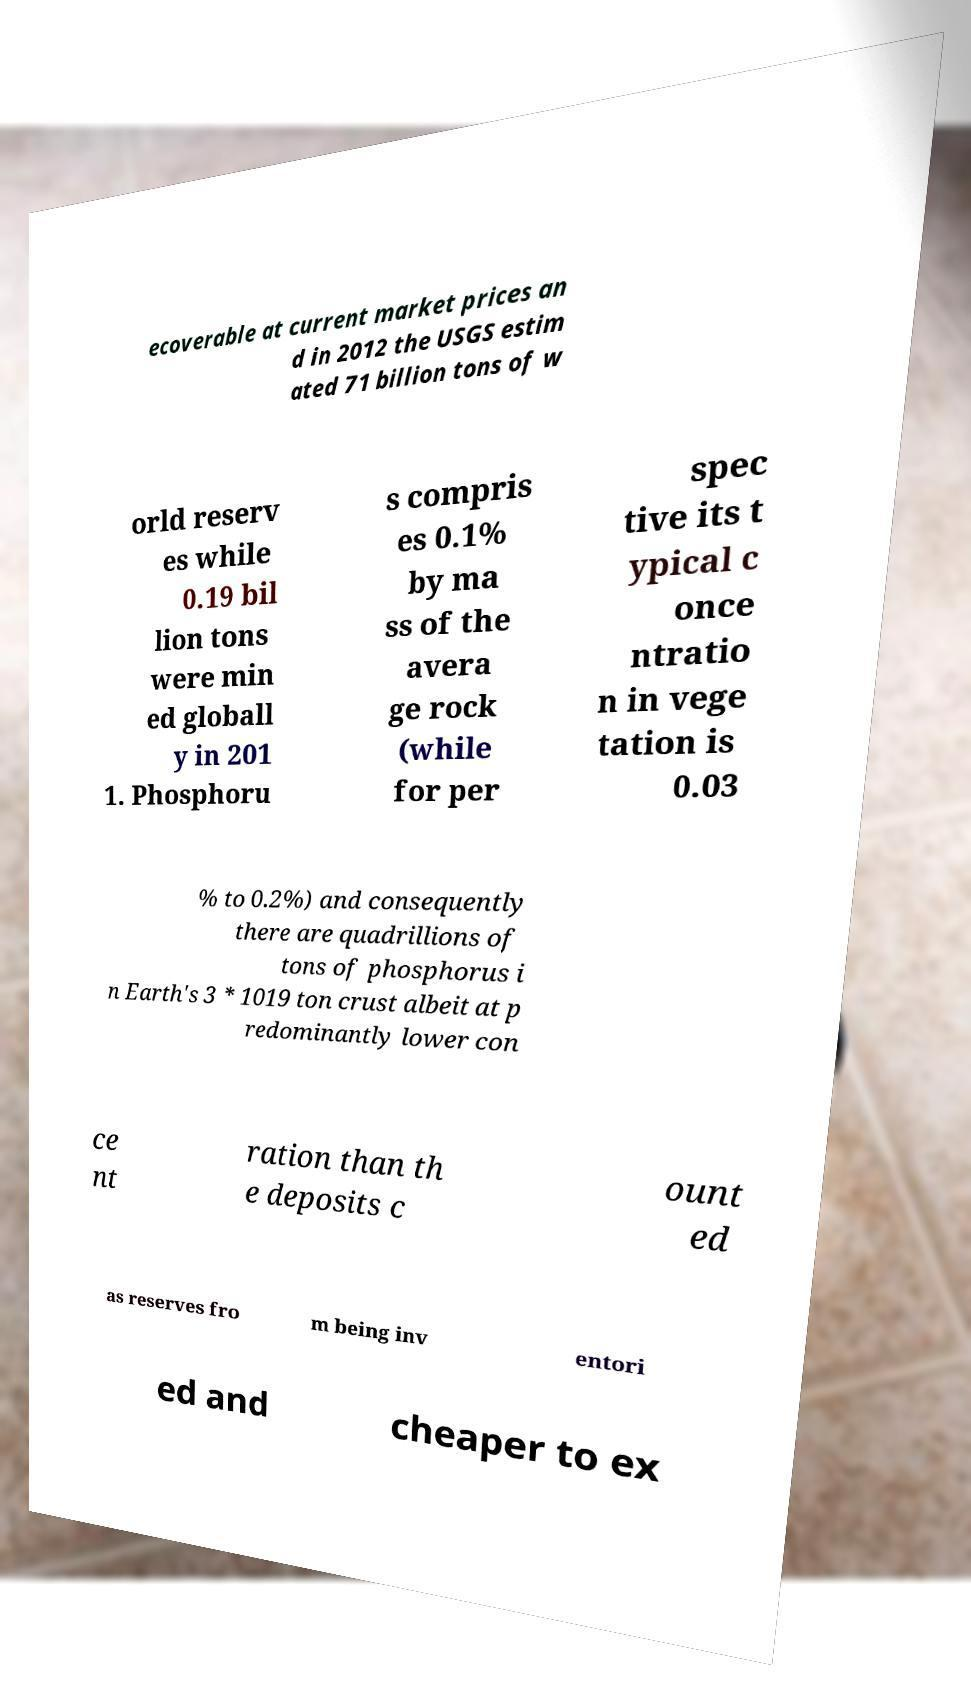Please read and relay the text visible in this image. What does it say? ecoverable at current market prices an d in 2012 the USGS estim ated 71 billion tons of w orld reserv es while 0.19 bil lion tons were min ed globall y in 201 1. Phosphoru s compris es 0.1% by ma ss of the avera ge rock (while for per spec tive its t ypical c once ntratio n in vege tation is 0.03 % to 0.2%) and consequently there are quadrillions of tons of phosphorus i n Earth's 3 * 1019 ton crust albeit at p redominantly lower con ce nt ration than th e deposits c ount ed as reserves fro m being inv entori ed and cheaper to ex 